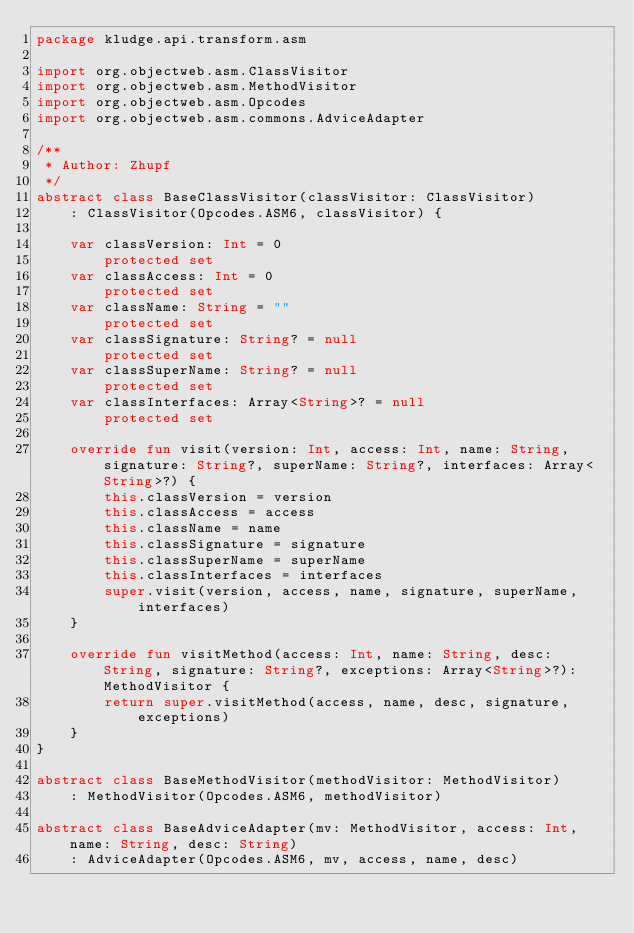<code> <loc_0><loc_0><loc_500><loc_500><_Kotlin_>package kludge.api.transform.asm

import org.objectweb.asm.ClassVisitor
import org.objectweb.asm.MethodVisitor
import org.objectweb.asm.Opcodes
import org.objectweb.asm.commons.AdviceAdapter

/**
 * Author: Zhupf
 */
abstract class BaseClassVisitor(classVisitor: ClassVisitor)
    : ClassVisitor(Opcodes.ASM6, classVisitor) {

    var classVersion: Int = 0
        protected set
    var classAccess: Int = 0
        protected set
    var className: String = ""
        protected set
    var classSignature: String? = null
        protected set
    var classSuperName: String? = null
        protected set
    var classInterfaces: Array<String>? = null
        protected set

    override fun visit(version: Int, access: Int, name: String, signature: String?, superName: String?, interfaces: Array<String>?) {
        this.classVersion = version
        this.classAccess = access
        this.className = name
        this.classSignature = signature
        this.classSuperName = superName
        this.classInterfaces = interfaces
        super.visit(version, access, name, signature, superName, interfaces)
    }

    override fun visitMethod(access: Int, name: String, desc: String, signature: String?, exceptions: Array<String>?): MethodVisitor {
        return super.visitMethod(access, name, desc, signature, exceptions)
    }
}

abstract class BaseMethodVisitor(methodVisitor: MethodVisitor)
    : MethodVisitor(Opcodes.ASM6, methodVisitor)

abstract class BaseAdviceAdapter(mv: MethodVisitor, access: Int, name: String, desc: String)
    : AdviceAdapter(Opcodes.ASM6, mv, access, name, desc)</code> 